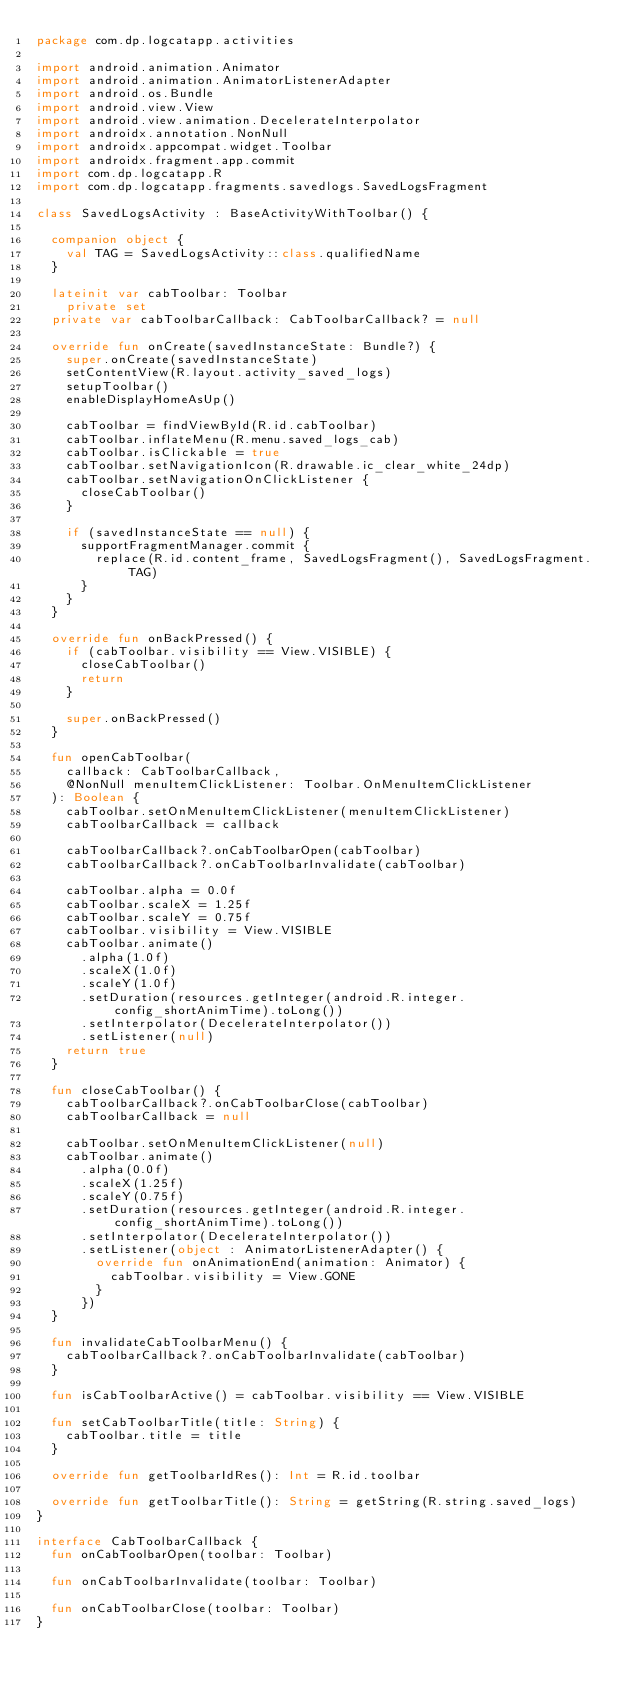Convert code to text. <code><loc_0><loc_0><loc_500><loc_500><_Kotlin_>package com.dp.logcatapp.activities

import android.animation.Animator
import android.animation.AnimatorListenerAdapter
import android.os.Bundle
import android.view.View
import android.view.animation.DecelerateInterpolator
import androidx.annotation.NonNull
import androidx.appcompat.widget.Toolbar
import androidx.fragment.app.commit
import com.dp.logcatapp.R
import com.dp.logcatapp.fragments.savedlogs.SavedLogsFragment

class SavedLogsActivity : BaseActivityWithToolbar() {

  companion object {
    val TAG = SavedLogsActivity::class.qualifiedName
  }

  lateinit var cabToolbar: Toolbar
    private set
  private var cabToolbarCallback: CabToolbarCallback? = null

  override fun onCreate(savedInstanceState: Bundle?) {
    super.onCreate(savedInstanceState)
    setContentView(R.layout.activity_saved_logs)
    setupToolbar()
    enableDisplayHomeAsUp()

    cabToolbar = findViewById(R.id.cabToolbar)
    cabToolbar.inflateMenu(R.menu.saved_logs_cab)
    cabToolbar.isClickable = true
    cabToolbar.setNavigationIcon(R.drawable.ic_clear_white_24dp)
    cabToolbar.setNavigationOnClickListener {
      closeCabToolbar()
    }

    if (savedInstanceState == null) {
      supportFragmentManager.commit {
        replace(R.id.content_frame, SavedLogsFragment(), SavedLogsFragment.TAG)
      }
    }
  }

  override fun onBackPressed() {
    if (cabToolbar.visibility == View.VISIBLE) {
      closeCabToolbar()
      return
    }

    super.onBackPressed()
  }

  fun openCabToolbar(
    callback: CabToolbarCallback,
    @NonNull menuItemClickListener: Toolbar.OnMenuItemClickListener
  ): Boolean {
    cabToolbar.setOnMenuItemClickListener(menuItemClickListener)
    cabToolbarCallback = callback

    cabToolbarCallback?.onCabToolbarOpen(cabToolbar)
    cabToolbarCallback?.onCabToolbarInvalidate(cabToolbar)

    cabToolbar.alpha = 0.0f
    cabToolbar.scaleX = 1.25f
    cabToolbar.scaleY = 0.75f
    cabToolbar.visibility = View.VISIBLE
    cabToolbar.animate()
      .alpha(1.0f)
      .scaleX(1.0f)
      .scaleY(1.0f)
      .setDuration(resources.getInteger(android.R.integer.config_shortAnimTime).toLong())
      .setInterpolator(DecelerateInterpolator())
      .setListener(null)
    return true
  }

  fun closeCabToolbar() {
    cabToolbarCallback?.onCabToolbarClose(cabToolbar)
    cabToolbarCallback = null

    cabToolbar.setOnMenuItemClickListener(null)
    cabToolbar.animate()
      .alpha(0.0f)
      .scaleX(1.25f)
      .scaleY(0.75f)
      .setDuration(resources.getInteger(android.R.integer.config_shortAnimTime).toLong())
      .setInterpolator(DecelerateInterpolator())
      .setListener(object : AnimatorListenerAdapter() {
        override fun onAnimationEnd(animation: Animator) {
          cabToolbar.visibility = View.GONE
        }
      })
  }

  fun invalidateCabToolbarMenu() {
    cabToolbarCallback?.onCabToolbarInvalidate(cabToolbar)
  }

  fun isCabToolbarActive() = cabToolbar.visibility == View.VISIBLE

  fun setCabToolbarTitle(title: String) {
    cabToolbar.title = title
  }

  override fun getToolbarIdRes(): Int = R.id.toolbar

  override fun getToolbarTitle(): String = getString(R.string.saved_logs)
}

interface CabToolbarCallback {
  fun onCabToolbarOpen(toolbar: Toolbar)

  fun onCabToolbarInvalidate(toolbar: Toolbar)

  fun onCabToolbarClose(toolbar: Toolbar)
}</code> 